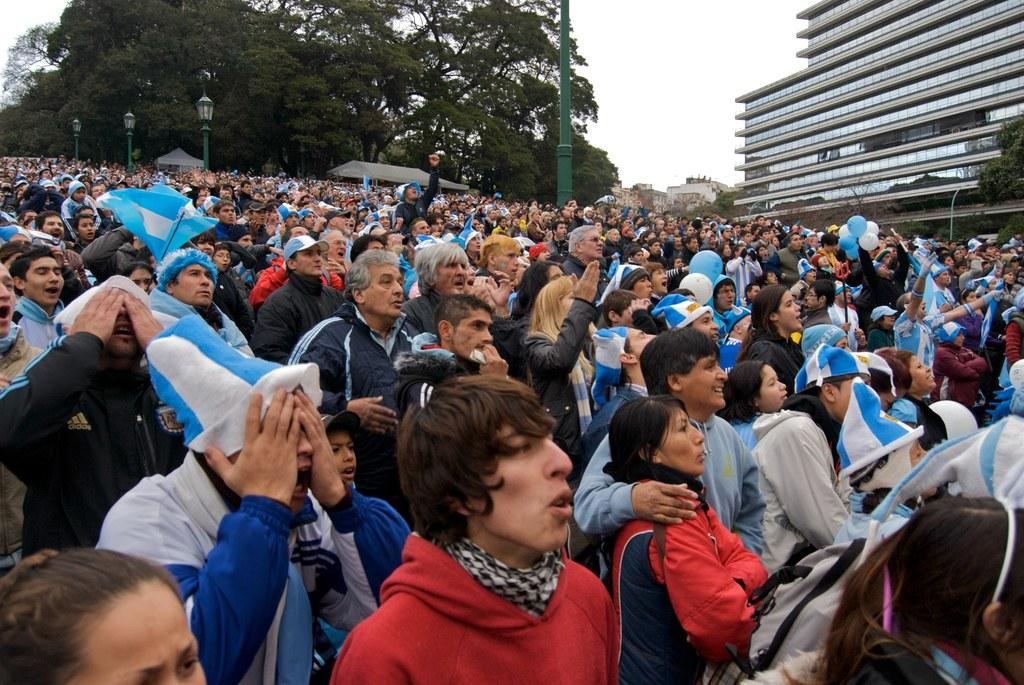What is happening on the road in the image? There is a crowd on the road in the image. What can be seen in the distance behind the crowd? There are buildings, trees, light poles, and the sky visible in the background of the image. Can you describe the time of day the image was taken? The image is likely taken during the day, as the sky is visible and there is no indication of darkness. What advice does the grandmother give to the society in the image? There is no grandmother or any indication of a society in the image; it simply shows a crowd on the road with background elements. 